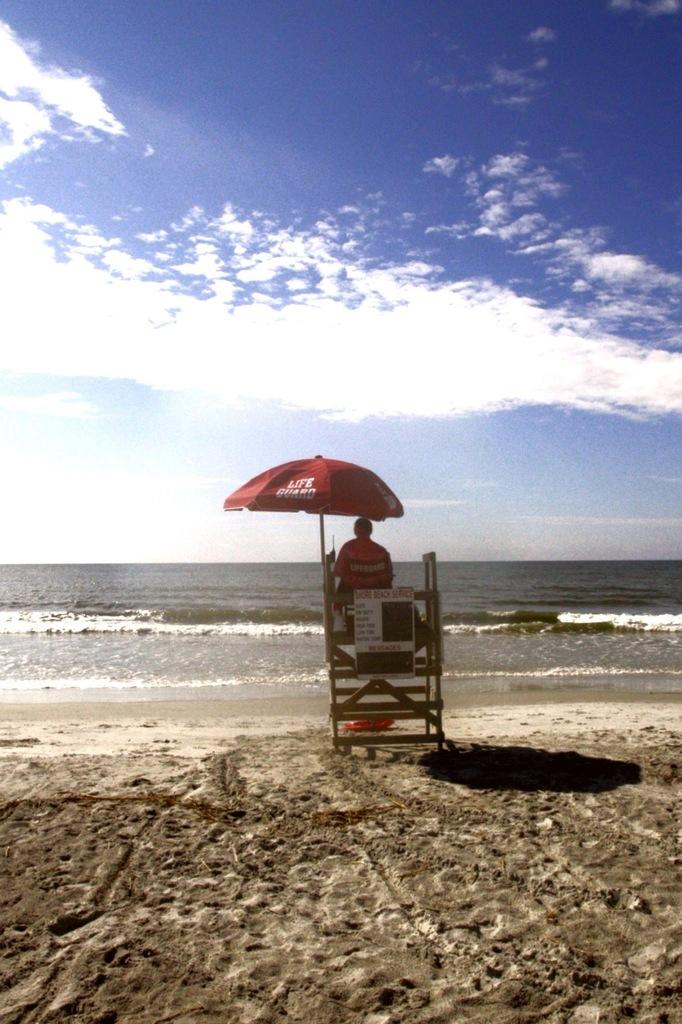What is the person sitting on in the image? The person is sitting on a wooden structure. What type of shelter is present in the image? The person is under a tent. What can be seen in front of the person? There is sea visible in front of the person. What is visible at the top of the image? The sky is visible at the top of the image. What can be observed about the sky in the image? There are clouds in the sky. How does the person add numbers while sitting on the wooden structure? There is no indication in the image that the person is adding numbers or performing any mathematical calculations. 